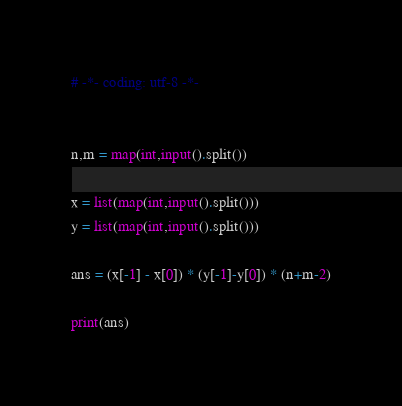<code> <loc_0><loc_0><loc_500><loc_500><_Python_># -*- coding: utf-8 -*-


n,m = map(int,input().split())

x = list(map(int,input().split()))
y = list(map(int,input().split()))

ans = (x[-1] - x[0]) * (y[-1]-y[0]) * (n+m-2)

print(ans)</code> 